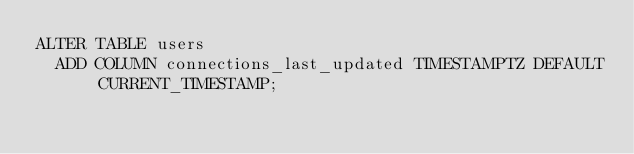Convert code to text. <code><loc_0><loc_0><loc_500><loc_500><_SQL_>ALTER TABLE users
  ADD COLUMN connections_last_updated TIMESTAMPTZ DEFAULT CURRENT_TIMESTAMP;
</code> 